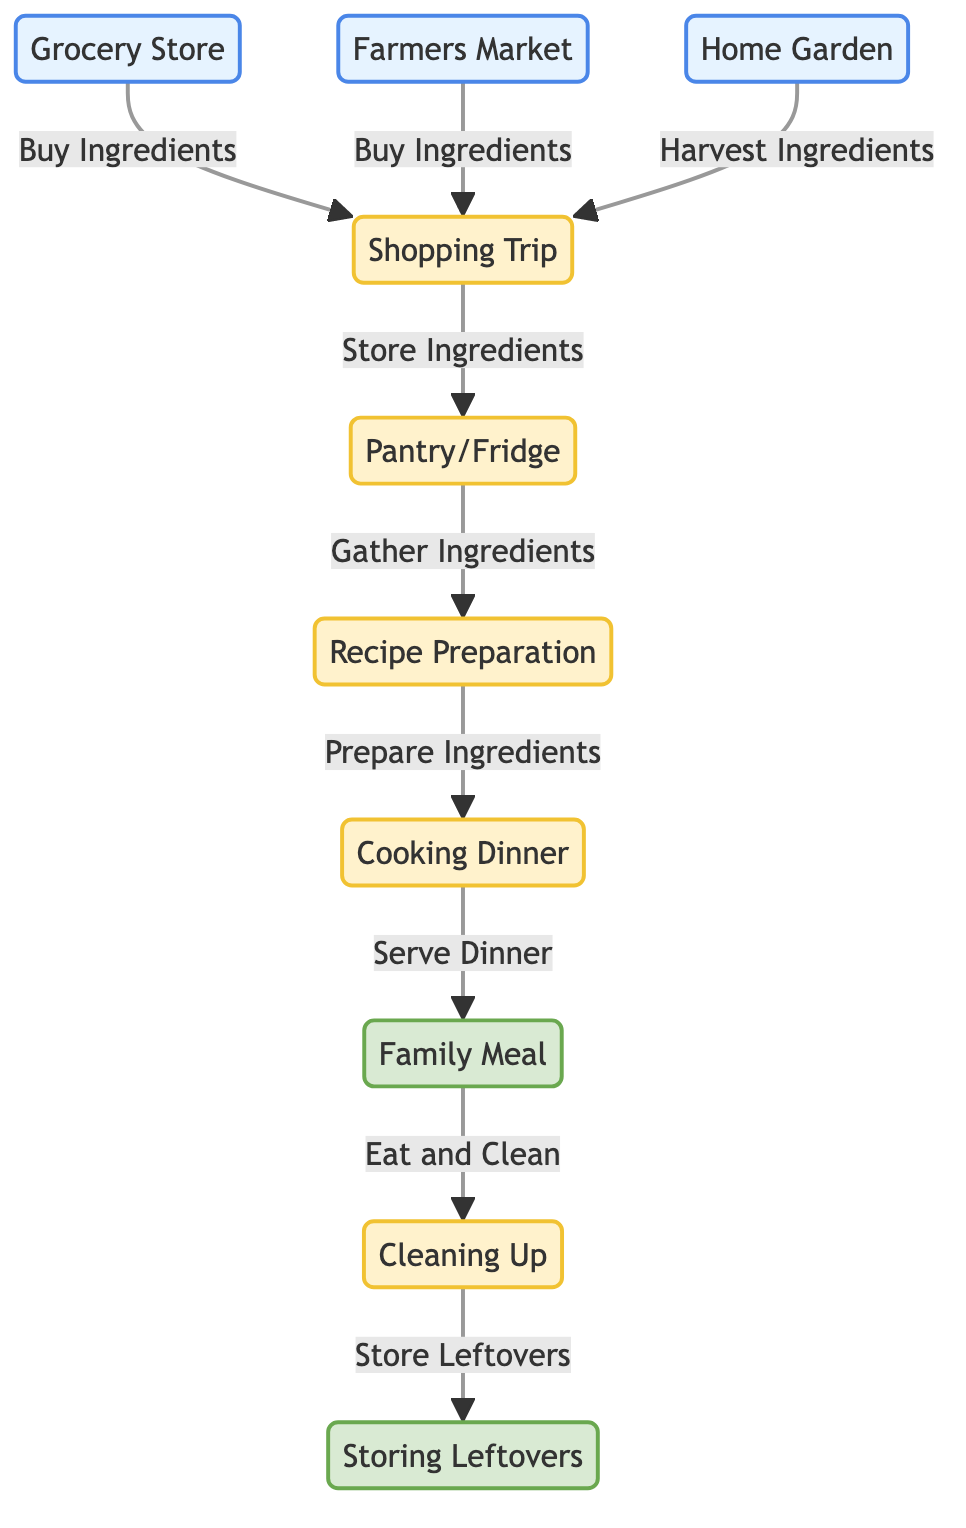What are the three sources of ingredients? The diagram shows three sources of ingredients, which are the Grocery Store, Farmers Market, and Home Garden. These nodes are visually identified under the "source" class.
Answer: Grocery Store, Farmers Market, Home Garden How many processes are involved in the family dinner evolution? There are five processes involved: Shopping Trip, Ingredient Storage, Recipe Preparation, Cooking Dinner, and Cleaning Up. These nodes are visually identified under the "process" class.
Answer: 5 What is the final outcome of the dinner process? The diagram indicates two final outcomes: the Family Meal and Storing Leftovers. These nodes are visually identified under the "final" class.
Answer: Family Meal, Storing Leftovers What links directly to Recipe Preparation? According to the diagram, Ingredient Storage links directly to Recipe Preparation, indicating that ingredients are gathered from storage before preparation.
Answer: Ingredient Storage What happens after Cooking Dinner? After Cooking Dinner, the next step in the flow is serving the Family Meal. This indicates that the preparation leads directly to the meal being served.
Answer: Family Meal How do ingredients get stored after cleaning up? After cleaning up, the leftover food is stored in leftovers storage, which directly follows the Cleaning Up process.
Answer: Leftovers Storage Which source involves harvesting ingredients? The Home Garden is the source that involves harvesting ingredients. This is indicated in the diagram with a specific link to the Shopping Trip process.
Answer: Home Garden Which processes come before the Family Meal? The processes that come before the Family Meal are Cooking Dinner and Recipe Preparation. Both processes lead up to serving the meal.
Answer: Cooking Dinner, Recipe Preparation What is the direct action taken at the Grocery Store? The direct action taken at the Grocery Store is buying ingredients, as illustrated in the flow from the Grocery Store to the Shopping Trip.
Answer: Buy Ingredients 